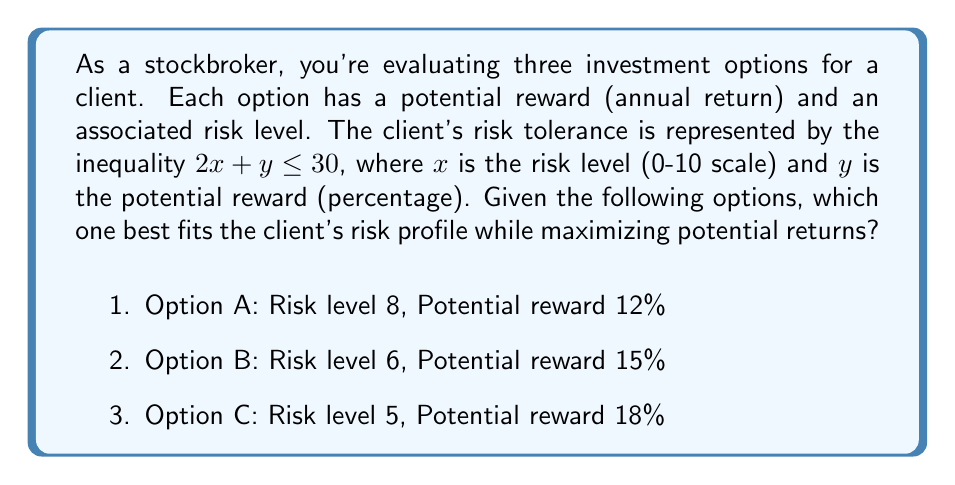Can you answer this question? To solve this problem, we need to evaluate each option against the client's risk tolerance inequality and choose the one that satisfies the constraint while offering the highest potential reward.

1. Evaluate the inequality for each option:

   For Option A: $2(8) + 12 \leq 30$
                 $16 + 12 = 28 \leq 30$ (Satisfies the constraint)

   For Option B: $2(6) + 15 \leq 30$
                 $12 + 15 = 27 \leq 30$ (Satisfies the constraint)

   For Option C: $2(5) + 18 \leq 30$
                 $10 + 18 = 28 \leq 30$ (Satisfies the constraint)

2. All three options satisfy the risk tolerance inequality.

3. Compare the potential rewards:
   Option A: 12%
   Option B: 15%
   Option C: 18%

4. Option C offers the highest potential reward while still satisfying the risk tolerance constraint.
Answer: Option C (Risk level 5, Potential reward 18%) 